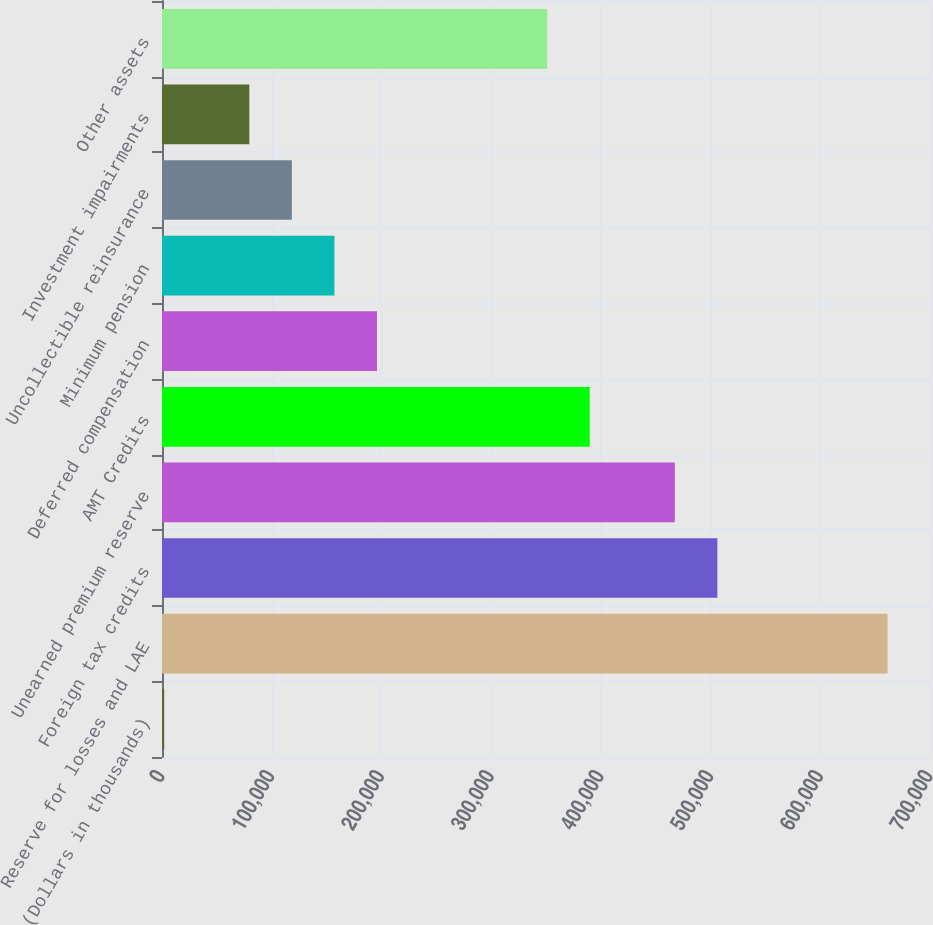Convert chart. <chart><loc_0><loc_0><loc_500><loc_500><bar_chart><fcel>(Dollars in thousands)<fcel>Reserve for losses and LAE<fcel>Foreign tax credits<fcel>Unearned premium reserve<fcel>AMT Credits<fcel>Deferred compensation<fcel>Minimum pension<fcel>Uncollectible reinsurance<fcel>Investment impairments<fcel>Other assets<nl><fcel>2010<fcel>661323<fcel>506190<fcel>467407<fcel>389841<fcel>195926<fcel>157142<fcel>118359<fcel>79576.2<fcel>351058<nl></chart> 